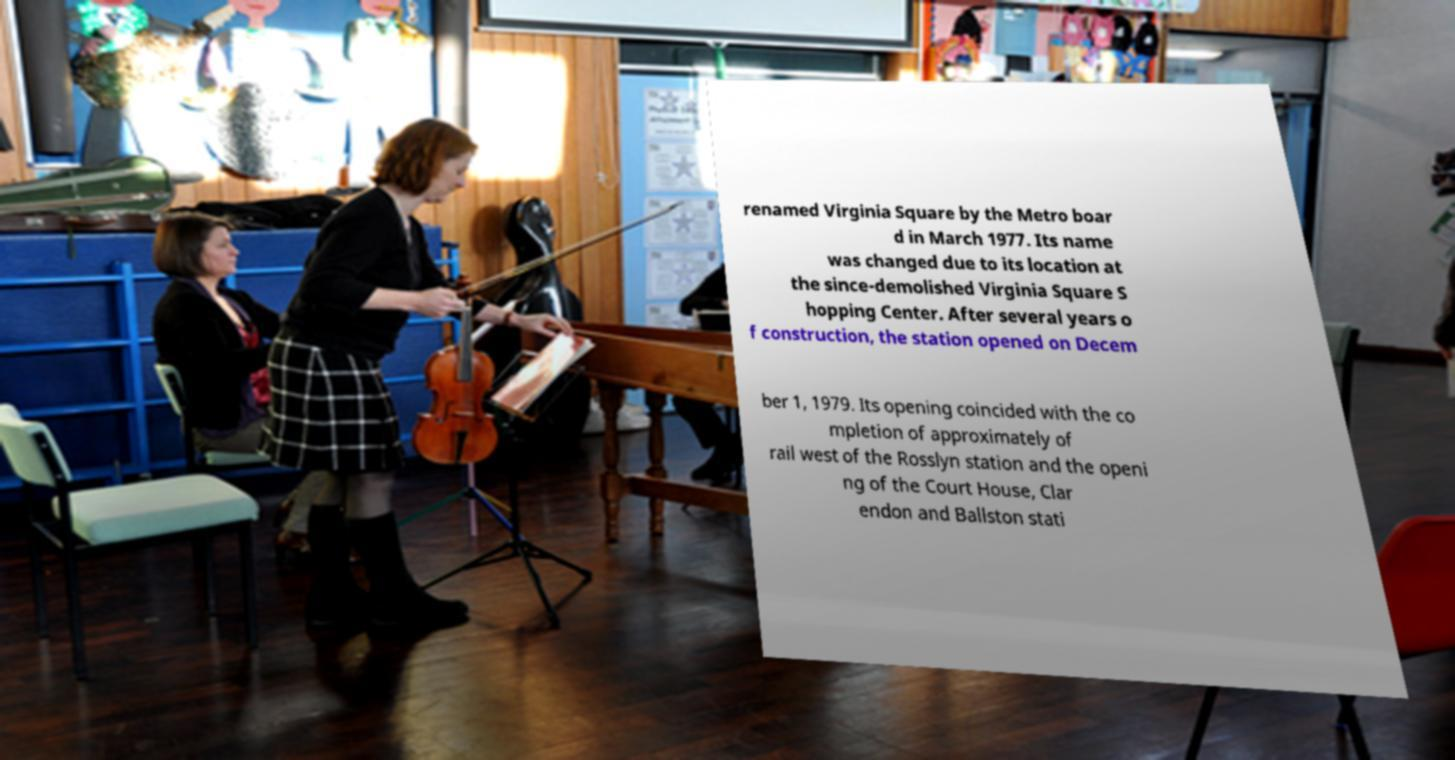Please identify and transcribe the text found in this image. renamed Virginia Square by the Metro boar d in March 1977. Its name was changed due to its location at the since-demolished Virginia Square S hopping Center. After several years o f construction, the station opened on Decem ber 1, 1979. Its opening coincided with the co mpletion of approximately of rail west of the Rosslyn station and the openi ng of the Court House, Clar endon and Ballston stati 